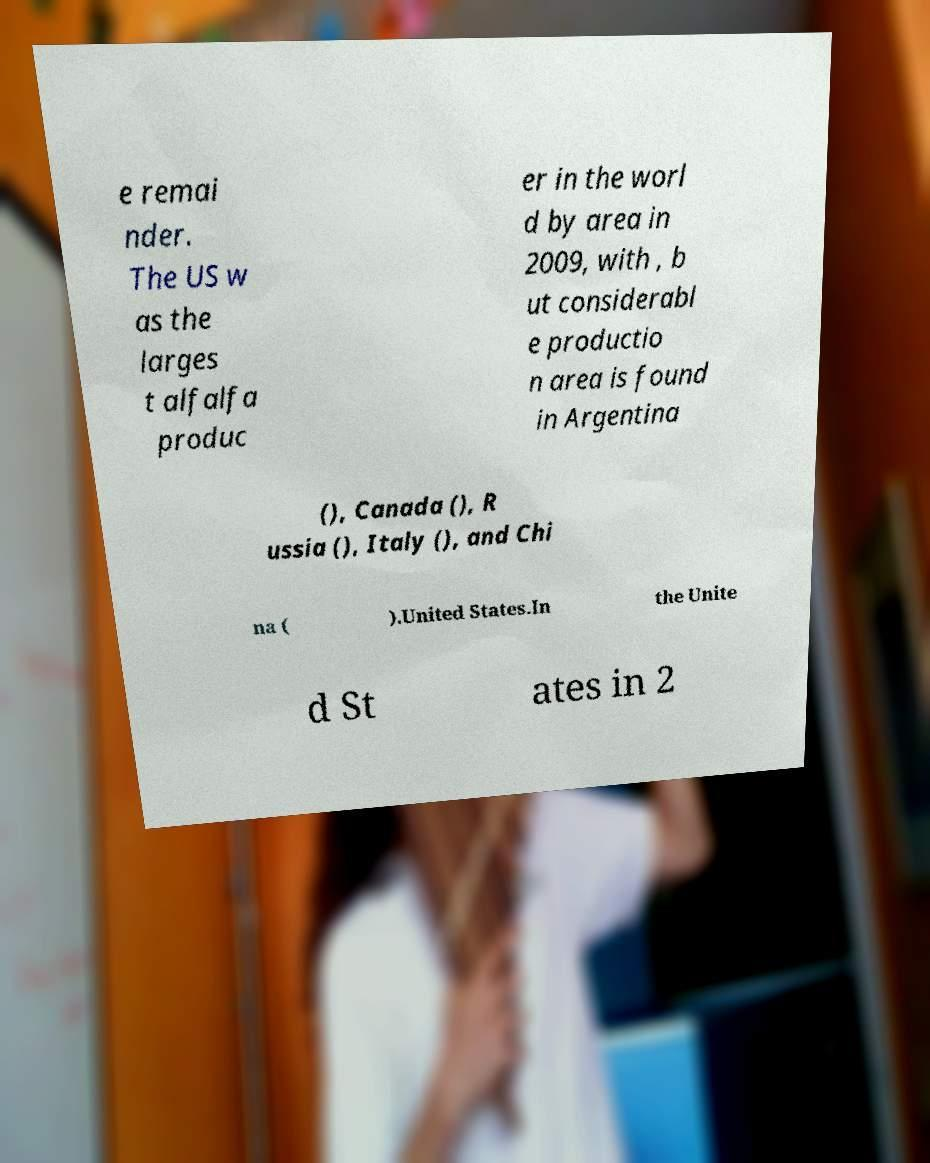I need the written content from this picture converted into text. Can you do that? e remai nder. The US w as the larges t alfalfa produc er in the worl d by area in 2009, with , b ut considerabl e productio n area is found in Argentina (), Canada (), R ussia (), Italy (), and Chi na ( ).United States.In the Unite d St ates in 2 